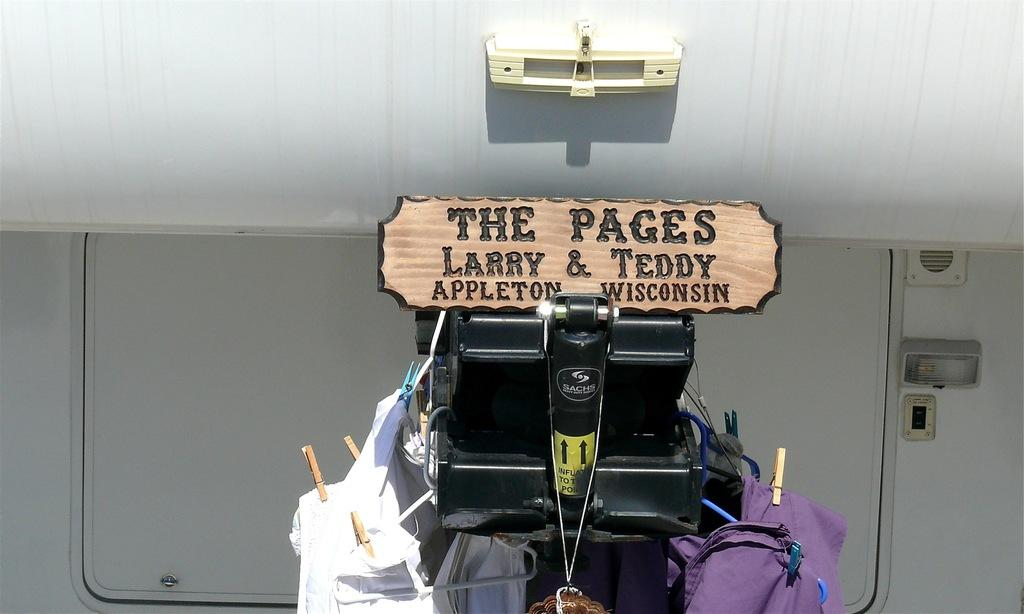What type of materials can be seen in the background of the image? There are metal panels and objects in the background of the image. What are the clothespins used for in the image? The purpose of the clothespins is not explicitly stated, but they are likely used for hanging or securing items. What is written or displayed on the board in the image? There is some information on the board in the image, but the specific content is not mentioned. Where is the lunchroom located in the image? There is no mention of a lunchroom in the image; it only features metal panels, objects, clothespins, and a board. What type of lip can be seen on the board in the image? There is no lip visible on the board in the image. 